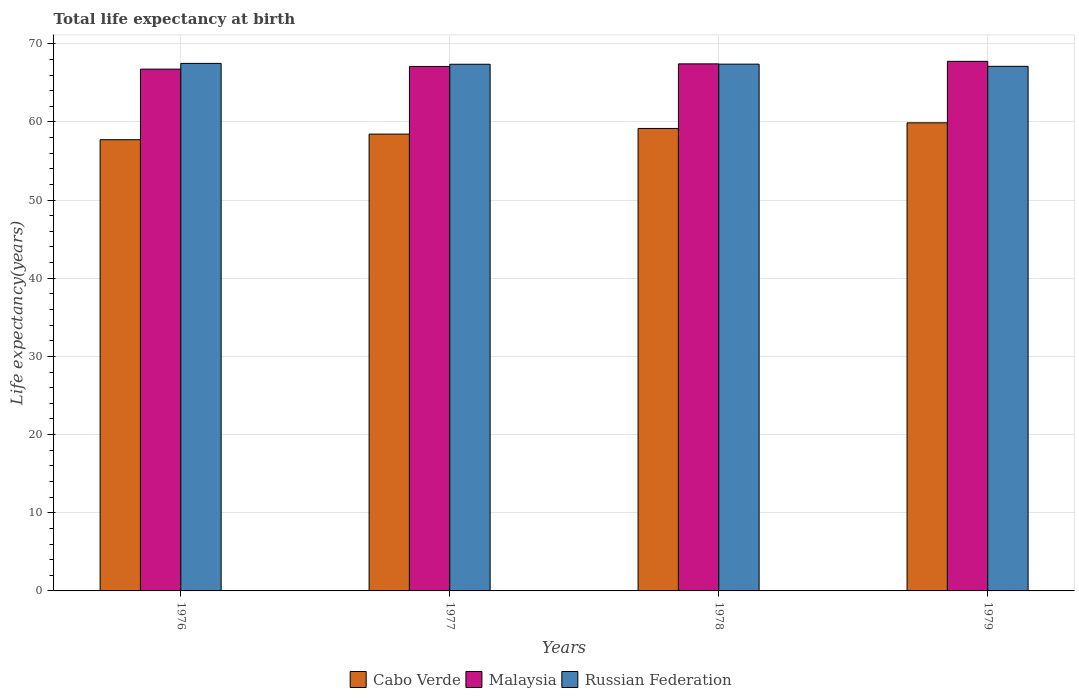What is the label of the 1st group of bars from the left?
Your answer should be very brief. 1976. In how many cases, is the number of bars for a given year not equal to the number of legend labels?
Offer a terse response. 0. What is the life expectancy at birth in in Malaysia in 1977?
Offer a very short reply. 67.1. Across all years, what is the maximum life expectancy at birth in in Russian Federation?
Provide a short and direct response. 67.49. Across all years, what is the minimum life expectancy at birth in in Cabo Verde?
Your answer should be compact. 57.72. In which year was the life expectancy at birth in in Malaysia maximum?
Provide a short and direct response. 1979. In which year was the life expectancy at birth in in Malaysia minimum?
Your answer should be compact. 1976. What is the total life expectancy at birth in in Cabo Verde in the graph?
Keep it short and to the point. 235.22. What is the difference between the life expectancy at birth in in Malaysia in 1976 and that in 1979?
Give a very brief answer. -0.99. What is the difference between the life expectancy at birth in in Russian Federation in 1976 and the life expectancy at birth in in Malaysia in 1978?
Your answer should be compact. 0.06. What is the average life expectancy at birth in in Malaysia per year?
Your answer should be compact. 67.26. In the year 1979, what is the difference between the life expectancy at birth in in Russian Federation and life expectancy at birth in in Cabo Verde?
Offer a very short reply. 7.23. What is the ratio of the life expectancy at birth in in Cabo Verde in 1976 to that in 1977?
Provide a succinct answer. 0.99. Is the life expectancy at birth in in Russian Federation in 1977 less than that in 1979?
Your answer should be compact. No. What is the difference between the highest and the second highest life expectancy at birth in in Malaysia?
Give a very brief answer. 0.32. What is the difference between the highest and the lowest life expectancy at birth in in Cabo Verde?
Your answer should be very brief. 2.16. In how many years, is the life expectancy at birth in in Malaysia greater than the average life expectancy at birth in in Malaysia taken over all years?
Offer a terse response. 2. What does the 1st bar from the left in 1978 represents?
Ensure brevity in your answer.  Cabo Verde. What does the 1st bar from the right in 1976 represents?
Ensure brevity in your answer.  Russian Federation. How many years are there in the graph?
Keep it short and to the point. 4. Are the values on the major ticks of Y-axis written in scientific E-notation?
Make the answer very short. No. How are the legend labels stacked?
Make the answer very short. Horizontal. What is the title of the graph?
Your response must be concise. Total life expectancy at birth. Does "Mauritania" appear as one of the legend labels in the graph?
Make the answer very short. No. What is the label or title of the Y-axis?
Offer a terse response. Life expectancy(years). What is the Life expectancy(years) of Cabo Verde in 1976?
Provide a short and direct response. 57.72. What is the Life expectancy(years) in Malaysia in 1976?
Offer a terse response. 66.75. What is the Life expectancy(years) of Russian Federation in 1976?
Provide a short and direct response. 67.49. What is the Life expectancy(years) of Cabo Verde in 1977?
Make the answer very short. 58.44. What is the Life expectancy(years) of Malaysia in 1977?
Give a very brief answer. 67.1. What is the Life expectancy(years) in Russian Federation in 1977?
Ensure brevity in your answer.  67.38. What is the Life expectancy(years) in Cabo Verde in 1978?
Offer a very short reply. 59.17. What is the Life expectancy(years) in Malaysia in 1978?
Ensure brevity in your answer.  67.43. What is the Life expectancy(years) of Russian Federation in 1978?
Your response must be concise. 67.39. What is the Life expectancy(years) of Cabo Verde in 1979?
Provide a succinct answer. 59.88. What is the Life expectancy(years) of Malaysia in 1979?
Your answer should be very brief. 67.75. What is the Life expectancy(years) in Russian Federation in 1979?
Keep it short and to the point. 67.11. Across all years, what is the maximum Life expectancy(years) of Cabo Verde?
Offer a very short reply. 59.88. Across all years, what is the maximum Life expectancy(years) of Malaysia?
Provide a succinct answer. 67.75. Across all years, what is the maximum Life expectancy(years) of Russian Federation?
Your answer should be very brief. 67.49. Across all years, what is the minimum Life expectancy(years) of Cabo Verde?
Give a very brief answer. 57.72. Across all years, what is the minimum Life expectancy(years) in Malaysia?
Offer a terse response. 66.75. Across all years, what is the minimum Life expectancy(years) in Russian Federation?
Keep it short and to the point. 67.11. What is the total Life expectancy(years) of Cabo Verde in the graph?
Your answer should be compact. 235.22. What is the total Life expectancy(years) of Malaysia in the graph?
Your answer should be very brief. 269.03. What is the total Life expectancy(years) of Russian Federation in the graph?
Your answer should be compact. 269.37. What is the difference between the Life expectancy(years) of Cabo Verde in 1976 and that in 1977?
Offer a terse response. -0.72. What is the difference between the Life expectancy(years) in Malaysia in 1976 and that in 1977?
Provide a short and direct response. -0.34. What is the difference between the Life expectancy(years) in Russian Federation in 1976 and that in 1977?
Give a very brief answer. 0.11. What is the difference between the Life expectancy(years) in Cabo Verde in 1976 and that in 1978?
Your response must be concise. -1.44. What is the difference between the Life expectancy(years) in Malaysia in 1976 and that in 1978?
Provide a short and direct response. -0.67. What is the difference between the Life expectancy(years) in Russian Federation in 1976 and that in 1978?
Provide a short and direct response. 0.1. What is the difference between the Life expectancy(years) of Cabo Verde in 1976 and that in 1979?
Offer a very short reply. -2.16. What is the difference between the Life expectancy(years) of Malaysia in 1976 and that in 1979?
Keep it short and to the point. -0.99. What is the difference between the Life expectancy(years) of Russian Federation in 1976 and that in 1979?
Ensure brevity in your answer.  0.37. What is the difference between the Life expectancy(years) of Cabo Verde in 1977 and that in 1978?
Your answer should be compact. -0.72. What is the difference between the Life expectancy(years) in Malaysia in 1977 and that in 1978?
Offer a very short reply. -0.33. What is the difference between the Life expectancy(years) of Russian Federation in 1977 and that in 1978?
Ensure brevity in your answer.  -0.01. What is the difference between the Life expectancy(years) of Cabo Verde in 1977 and that in 1979?
Your response must be concise. -1.44. What is the difference between the Life expectancy(years) in Malaysia in 1977 and that in 1979?
Your answer should be very brief. -0.65. What is the difference between the Life expectancy(years) of Russian Federation in 1977 and that in 1979?
Ensure brevity in your answer.  0.26. What is the difference between the Life expectancy(years) in Cabo Verde in 1978 and that in 1979?
Offer a terse response. -0.72. What is the difference between the Life expectancy(years) of Malaysia in 1978 and that in 1979?
Your response must be concise. -0.32. What is the difference between the Life expectancy(years) of Russian Federation in 1978 and that in 1979?
Make the answer very short. 0.28. What is the difference between the Life expectancy(years) in Cabo Verde in 1976 and the Life expectancy(years) in Malaysia in 1977?
Offer a very short reply. -9.37. What is the difference between the Life expectancy(years) in Cabo Verde in 1976 and the Life expectancy(years) in Russian Federation in 1977?
Provide a short and direct response. -9.65. What is the difference between the Life expectancy(years) in Malaysia in 1976 and the Life expectancy(years) in Russian Federation in 1977?
Give a very brief answer. -0.62. What is the difference between the Life expectancy(years) of Cabo Verde in 1976 and the Life expectancy(years) of Malaysia in 1978?
Provide a short and direct response. -9.7. What is the difference between the Life expectancy(years) in Cabo Verde in 1976 and the Life expectancy(years) in Russian Federation in 1978?
Give a very brief answer. -9.67. What is the difference between the Life expectancy(years) in Malaysia in 1976 and the Life expectancy(years) in Russian Federation in 1978?
Give a very brief answer. -0.64. What is the difference between the Life expectancy(years) of Cabo Verde in 1976 and the Life expectancy(years) of Malaysia in 1979?
Make the answer very short. -10.02. What is the difference between the Life expectancy(years) in Cabo Verde in 1976 and the Life expectancy(years) in Russian Federation in 1979?
Provide a succinct answer. -9.39. What is the difference between the Life expectancy(years) in Malaysia in 1976 and the Life expectancy(years) in Russian Federation in 1979?
Provide a short and direct response. -0.36. What is the difference between the Life expectancy(years) in Cabo Verde in 1977 and the Life expectancy(years) in Malaysia in 1978?
Keep it short and to the point. -8.98. What is the difference between the Life expectancy(years) in Cabo Verde in 1977 and the Life expectancy(years) in Russian Federation in 1978?
Provide a short and direct response. -8.95. What is the difference between the Life expectancy(years) of Malaysia in 1977 and the Life expectancy(years) of Russian Federation in 1978?
Provide a short and direct response. -0.29. What is the difference between the Life expectancy(years) in Cabo Verde in 1977 and the Life expectancy(years) in Malaysia in 1979?
Your answer should be very brief. -9.31. What is the difference between the Life expectancy(years) in Cabo Verde in 1977 and the Life expectancy(years) in Russian Federation in 1979?
Offer a terse response. -8.67. What is the difference between the Life expectancy(years) in Malaysia in 1977 and the Life expectancy(years) in Russian Federation in 1979?
Offer a very short reply. -0.02. What is the difference between the Life expectancy(years) in Cabo Verde in 1978 and the Life expectancy(years) in Malaysia in 1979?
Your answer should be compact. -8.58. What is the difference between the Life expectancy(years) in Cabo Verde in 1978 and the Life expectancy(years) in Russian Federation in 1979?
Keep it short and to the point. -7.95. What is the difference between the Life expectancy(years) in Malaysia in 1978 and the Life expectancy(years) in Russian Federation in 1979?
Make the answer very short. 0.31. What is the average Life expectancy(years) of Cabo Verde per year?
Offer a terse response. 58.8. What is the average Life expectancy(years) of Malaysia per year?
Keep it short and to the point. 67.26. What is the average Life expectancy(years) of Russian Federation per year?
Ensure brevity in your answer.  67.34. In the year 1976, what is the difference between the Life expectancy(years) of Cabo Verde and Life expectancy(years) of Malaysia?
Ensure brevity in your answer.  -9.03. In the year 1976, what is the difference between the Life expectancy(years) of Cabo Verde and Life expectancy(years) of Russian Federation?
Your answer should be compact. -9.76. In the year 1976, what is the difference between the Life expectancy(years) of Malaysia and Life expectancy(years) of Russian Federation?
Your answer should be compact. -0.73. In the year 1977, what is the difference between the Life expectancy(years) of Cabo Verde and Life expectancy(years) of Malaysia?
Your response must be concise. -8.65. In the year 1977, what is the difference between the Life expectancy(years) of Cabo Verde and Life expectancy(years) of Russian Federation?
Provide a succinct answer. -8.93. In the year 1977, what is the difference between the Life expectancy(years) in Malaysia and Life expectancy(years) in Russian Federation?
Provide a short and direct response. -0.28. In the year 1978, what is the difference between the Life expectancy(years) of Cabo Verde and Life expectancy(years) of Malaysia?
Ensure brevity in your answer.  -8.26. In the year 1978, what is the difference between the Life expectancy(years) of Cabo Verde and Life expectancy(years) of Russian Federation?
Offer a very short reply. -8.23. In the year 1978, what is the difference between the Life expectancy(years) of Malaysia and Life expectancy(years) of Russian Federation?
Provide a short and direct response. 0.04. In the year 1979, what is the difference between the Life expectancy(years) of Cabo Verde and Life expectancy(years) of Malaysia?
Your answer should be compact. -7.87. In the year 1979, what is the difference between the Life expectancy(years) in Cabo Verde and Life expectancy(years) in Russian Federation?
Provide a short and direct response. -7.23. In the year 1979, what is the difference between the Life expectancy(years) of Malaysia and Life expectancy(years) of Russian Federation?
Your response must be concise. 0.63. What is the ratio of the Life expectancy(years) in Cabo Verde in 1976 to that in 1977?
Your answer should be very brief. 0.99. What is the ratio of the Life expectancy(years) of Russian Federation in 1976 to that in 1977?
Your answer should be compact. 1. What is the ratio of the Life expectancy(years) of Cabo Verde in 1976 to that in 1978?
Keep it short and to the point. 0.98. What is the ratio of the Life expectancy(years) of Cabo Verde in 1976 to that in 1979?
Your response must be concise. 0.96. What is the ratio of the Life expectancy(years) in Malaysia in 1976 to that in 1979?
Ensure brevity in your answer.  0.99. What is the ratio of the Life expectancy(years) of Russian Federation in 1976 to that in 1979?
Give a very brief answer. 1.01. What is the ratio of the Life expectancy(years) of Cabo Verde in 1977 to that in 1978?
Your answer should be very brief. 0.99. What is the ratio of the Life expectancy(years) in Malaysia in 1977 to that in 1978?
Keep it short and to the point. 1. What is the ratio of the Life expectancy(years) of Cabo Verde in 1977 to that in 1979?
Keep it short and to the point. 0.98. What is the ratio of the Life expectancy(years) in Malaysia in 1977 to that in 1979?
Your answer should be compact. 0.99. What is the ratio of the Life expectancy(years) of Russian Federation in 1977 to that in 1979?
Make the answer very short. 1. What is the ratio of the Life expectancy(years) of Cabo Verde in 1978 to that in 1979?
Ensure brevity in your answer.  0.99. What is the difference between the highest and the second highest Life expectancy(years) of Cabo Verde?
Give a very brief answer. 0.72. What is the difference between the highest and the second highest Life expectancy(years) of Malaysia?
Give a very brief answer. 0.32. What is the difference between the highest and the second highest Life expectancy(years) in Russian Federation?
Give a very brief answer. 0.1. What is the difference between the highest and the lowest Life expectancy(years) of Cabo Verde?
Your response must be concise. 2.16. What is the difference between the highest and the lowest Life expectancy(years) in Russian Federation?
Provide a succinct answer. 0.37. 